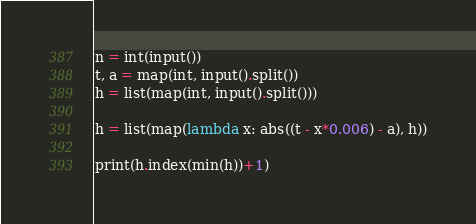Convert code to text. <code><loc_0><loc_0><loc_500><loc_500><_Python_>n = int(input())
t, a = map(int, input().split())
h = list(map(int, input().split()))

h = list(map(lambda x: abs((t - x*0.006) - a), h))

print(h.index(min(h))+1)</code> 